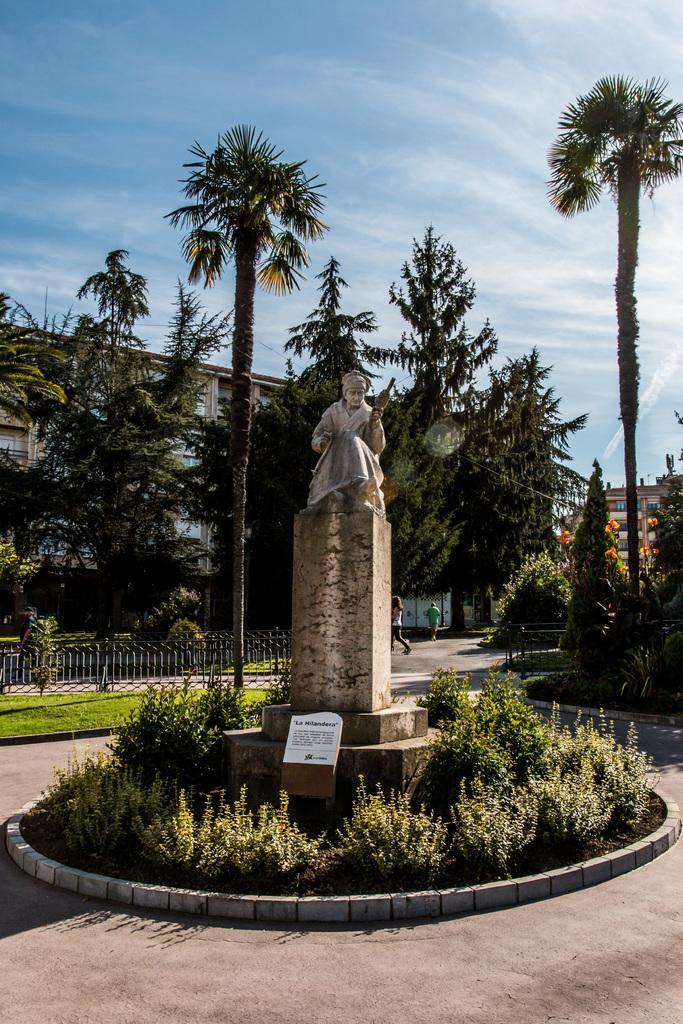How would you summarize this image in a sentence or two? In the center of the image there is a statue. There is a board with some text on it. There are plants. In the background of the image there is a metal fence. There are people running on the road. There are buildings, trees and sky. 